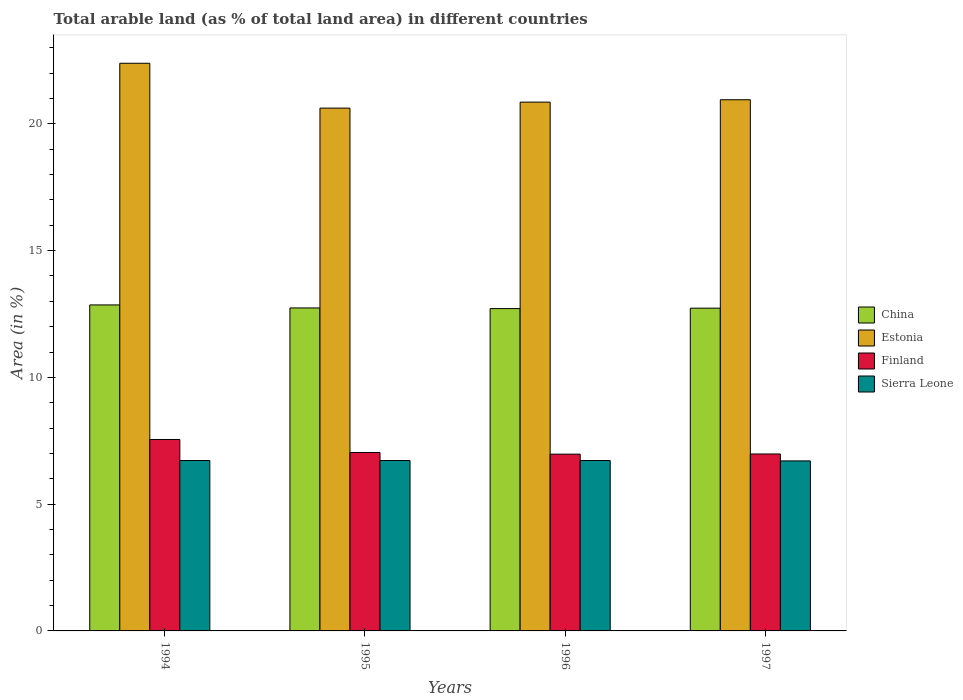How many different coloured bars are there?
Your answer should be compact. 4. How many groups of bars are there?
Make the answer very short. 4. Are the number of bars on each tick of the X-axis equal?
Your answer should be compact. Yes. How many bars are there on the 4th tick from the right?
Offer a very short reply. 4. What is the percentage of arable land in Estonia in 1994?
Make the answer very short. 22.39. Across all years, what is the maximum percentage of arable land in Finland?
Offer a terse response. 7.55. Across all years, what is the minimum percentage of arable land in China?
Provide a succinct answer. 12.71. In which year was the percentage of arable land in Estonia maximum?
Ensure brevity in your answer.  1994. What is the total percentage of arable land in Estonia in the graph?
Your answer should be compact. 84.81. What is the difference between the percentage of arable land in Finland in 1996 and the percentage of arable land in Estonia in 1994?
Ensure brevity in your answer.  -15.42. What is the average percentage of arable land in Estonia per year?
Give a very brief answer. 21.2. In the year 1994, what is the difference between the percentage of arable land in Finland and percentage of arable land in Estonia?
Your answer should be compact. -14.84. What is the ratio of the percentage of arable land in Finland in 1994 to that in 1995?
Provide a succinct answer. 1.07. What is the difference between the highest and the second highest percentage of arable land in Estonia?
Provide a succinct answer. 1.44. What is the difference between the highest and the lowest percentage of arable land in Estonia?
Provide a short and direct response. 1.77. What does the 4th bar from the left in 1995 represents?
Offer a terse response. Sierra Leone. What does the 1st bar from the right in 1994 represents?
Provide a short and direct response. Sierra Leone. Is it the case that in every year, the sum of the percentage of arable land in Finland and percentage of arable land in Estonia is greater than the percentage of arable land in Sierra Leone?
Your response must be concise. Yes. How many bars are there?
Your answer should be compact. 16. How many years are there in the graph?
Make the answer very short. 4. Are the values on the major ticks of Y-axis written in scientific E-notation?
Your answer should be very brief. No. Where does the legend appear in the graph?
Offer a terse response. Center right. How many legend labels are there?
Offer a very short reply. 4. How are the legend labels stacked?
Offer a terse response. Vertical. What is the title of the graph?
Your answer should be compact. Total arable land (as % of total land area) in different countries. What is the label or title of the Y-axis?
Provide a succinct answer. Area (in %). What is the Area (in %) of China in 1994?
Provide a succinct answer. 12.86. What is the Area (in %) in Estonia in 1994?
Keep it short and to the point. 22.39. What is the Area (in %) of Finland in 1994?
Keep it short and to the point. 7.55. What is the Area (in %) in Sierra Leone in 1994?
Provide a succinct answer. 6.72. What is the Area (in %) in China in 1995?
Make the answer very short. 12.74. What is the Area (in %) of Estonia in 1995?
Make the answer very short. 20.62. What is the Area (in %) in Finland in 1995?
Offer a terse response. 7.04. What is the Area (in %) of Sierra Leone in 1995?
Ensure brevity in your answer.  6.72. What is the Area (in %) in China in 1996?
Keep it short and to the point. 12.71. What is the Area (in %) in Estonia in 1996?
Provide a succinct answer. 20.85. What is the Area (in %) of Finland in 1996?
Ensure brevity in your answer.  6.97. What is the Area (in %) of Sierra Leone in 1996?
Offer a very short reply. 6.72. What is the Area (in %) of China in 1997?
Your answer should be compact. 12.73. What is the Area (in %) of Estonia in 1997?
Your response must be concise. 20.95. What is the Area (in %) of Finland in 1997?
Your answer should be compact. 6.98. What is the Area (in %) in Sierra Leone in 1997?
Provide a succinct answer. 6.71. Across all years, what is the maximum Area (in %) of China?
Give a very brief answer. 12.86. Across all years, what is the maximum Area (in %) of Estonia?
Provide a succinct answer. 22.39. Across all years, what is the maximum Area (in %) in Finland?
Provide a short and direct response. 7.55. Across all years, what is the maximum Area (in %) of Sierra Leone?
Offer a very short reply. 6.72. Across all years, what is the minimum Area (in %) in China?
Offer a terse response. 12.71. Across all years, what is the minimum Area (in %) in Estonia?
Make the answer very short. 20.62. Across all years, what is the minimum Area (in %) in Finland?
Make the answer very short. 6.97. Across all years, what is the minimum Area (in %) of Sierra Leone?
Provide a short and direct response. 6.71. What is the total Area (in %) in China in the graph?
Keep it short and to the point. 51.03. What is the total Area (in %) in Estonia in the graph?
Your answer should be compact. 84.81. What is the total Area (in %) in Finland in the graph?
Give a very brief answer. 28.54. What is the total Area (in %) of Sierra Leone in the graph?
Offer a terse response. 26.86. What is the difference between the Area (in %) in China in 1994 and that in 1995?
Your answer should be very brief. 0.12. What is the difference between the Area (in %) in Estonia in 1994 and that in 1995?
Provide a succinct answer. 1.77. What is the difference between the Area (in %) of Finland in 1994 and that in 1995?
Keep it short and to the point. 0.51. What is the difference between the Area (in %) in Sierra Leone in 1994 and that in 1995?
Your response must be concise. 0. What is the difference between the Area (in %) of China in 1994 and that in 1996?
Offer a terse response. 0.14. What is the difference between the Area (in %) of Estonia in 1994 and that in 1996?
Provide a succinct answer. 1.53. What is the difference between the Area (in %) in Finland in 1994 and that in 1996?
Provide a short and direct response. 0.58. What is the difference between the Area (in %) of Sierra Leone in 1994 and that in 1996?
Your answer should be compact. 0. What is the difference between the Area (in %) in China in 1994 and that in 1997?
Keep it short and to the point. 0.13. What is the difference between the Area (in %) in Estonia in 1994 and that in 1997?
Offer a terse response. 1.44. What is the difference between the Area (in %) of Finland in 1994 and that in 1997?
Your response must be concise. 0.57. What is the difference between the Area (in %) of Sierra Leone in 1994 and that in 1997?
Offer a terse response. 0.01. What is the difference between the Area (in %) of China in 1995 and that in 1996?
Offer a very short reply. 0.03. What is the difference between the Area (in %) in Estonia in 1995 and that in 1996?
Provide a short and direct response. -0.24. What is the difference between the Area (in %) in Finland in 1995 and that in 1996?
Keep it short and to the point. 0.07. What is the difference between the Area (in %) of Sierra Leone in 1995 and that in 1996?
Provide a succinct answer. 0. What is the difference between the Area (in %) in China in 1995 and that in 1997?
Your answer should be very brief. 0.01. What is the difference between the Area (in %) of Estonia in 1995 and that in 1997?
Your answer should be very brief. -0.33. What is the difference between the Area (in %) in Finland in 1995 and that in 1997?
Offer a terse response. 0.06. What is the difference between the Area (in %) of Sierra Leone in 1995 and that in 1997?
Ensure brevity in your answer.  0.01. What is the difference between the Area (in %) in China in 1996 and that in 1997?
Provide a short and direct response. -0.02. What is the difference between the Area (in %) of Estonia in 1996 and that in 1997?
Your answer should be very brief. -0.09. What is the difference between the Area (in %) of Finland in 1996 and that in 1997?
Make the answer very short. -0.01. What is the difference between the Area (in %) in Sierra Leone in 1996 and that in 1997?
Ensure brevity in your answer.  0.01. What is the difference between the Area (in %) in China in 1994 and the Area (in %) in Estonia in 1995?
Offer a terse response. -7.76. What is the difference between the Area (in %) in China in 1994 and the Area (in %) in Finland in 1995?
Provide a short and direct response. 5.82. What is the difference between the Area (in %) of China in 1994 and the Area (in %) of Sierra Leone in 1995?
Offer a very short reply. 6.14. What is the difference between the Area (in %) of Estonia in 1994 and the Area (in %) of Finland in 1995?
Give a very brief answer. 15.35. What is the difference between the Area (in %) of Estonia in 1994 and the Area (in %) of Sierra Leone in 1995?
Your answer should be very brief. 15.67. What is the difference between the Area (in %) of Finland in 1994 and the Area (in %) of Sierra Leone in 1995?
Provide a short and direct response. 0.83. What is the difference between the Area (in %) in China in 1994 and the Area (in %) in Estonia in 1996?
Offer a very short reply. -8. What is the difference between the Area (in %) of China in 1994 and the Area (in %) of Finland in 1996?
Provide a succinct answer. 5.89. What is the difference between the Area (in %) in China in 1994 and the Area (in %) in Sierra Leone in 1996?
Make the answer very short. 6.14. What is the difference between the Area (in %) of Estonia in 1994 and the Area (in %) of Finland in 1996?
Give a very brief answer. 15.42. What is the difference between the Area (in %) in Estonia in 1994 and the Area (in %) in Sierra Leone in 1996?
Make the answer very short. 15.67. What is the difference between the Area (in %) in Finland in 1994 and the Area (in %) in Sierra Leone in 1996?
Your response must be concise. 0.83. What is the difference between the Area (in %) of China in 1994 and the Area (in %) of Estonia in 1997?
Ensure brevity in your answer.  -8.09. What is the difference between the Area (in %) of China in 1994 and the Area (in %) of Finland in 1997?
Keep it short and to the point. 5.88. What is the difference between the Area (in %) in China in 1994 and the Area (in %) in Sierra Leone in 1997?
Offer a very short reply. 6.15. What is the difference between the Area (in %) of Estonia in 1994 and the Area (in %) of Finland in 1997?
Provide a succinct answer. 15.41. What is the difference between the Area (in %) of Estonia in 1994 and the Area (in %) of Sierra Leone in 1997?
Your answer should be very brief. 15.68. What is the difference between the Area (in %) in Finland in 1994 and the Area (in %) in Sierra Leone in 1997?
Keep it short and to the point. 0.84. What is the difference between the Area (in %) in China in 1995 and the Area (in %) in Estonia in 1996?
Offer a terse response. -8.12. What is the difference between the Area (in %) of China in 1995 and the Area (in %) of Finland in 1996?
Your response must be concise. 5.77. What is the difference between the Area (in %) of China in 1995 and the Area (in %) of Sierra Leone in 1996?
Offer a very short reply. 6.02. What is the difference between the Area (in %) of Estonia in 1995 and the Area (in %) of Finland in 1996?
Offer a very short reply. 13.65. What is the difference between the Area (in %) of Estonia in 1995 and the Area (in %) of Sierra Leone in 1996?
Keep it short and to the point. 13.9. What is the difference between the Area (in %) of Finland in 1995 and the Area (in %) of Sierra Leone in 1996?
Provide a succinct answer. 0.32. What is the difference between the Area (in %) of China in 1995 and the Area (in %) of Estonia in 1997?
Provide a short and direct response. -8.21. What is the difference between the Area (in %) in China in 1995 and the Area (in %) in Finland in 1997?
Your answer should be compact. 5.76. What is the difference between the Area (in %) in China in 1995 and the Area (in %) in Sierra Leone in 1997?
Give a very brief answer. 6.03. What is the difference between the Area (in %) in Estonia in 1995 and the Area (in %) in Finland in 1997?
Keep it short and to the point. 13.64. What is the difference between the Area (in %) in Estonia in 1995 and the Area (in %) in Sierra Leone in 1997?
Give a very brief answer. 13.91. What is the difference between the Area (in %) of Finland in 1995 and the Area (in %) of Sierra Leone in 1997?
Keep it short and to the point. 0.33. What is the difference between the Area (in %) in China in 1996 and the Area (in %) in Estonia in 1997?
Your response must be concise. -8.24. What is the difference between the Area (in %) of China in 1996 and the Area (in %) of Finland in 1997?
Your response must be concise. 5.73. What is the difference between the Area (in %) in China in 1996 and the Area (in %) in Sierra Leone in 1997?
Ensure brevity in your answer.  6.01. What is the difference between the Area (in %) of Estonia in 1996 and the Area (in %) of Finland in 1997?
Provide a succinct answer. 13.88. What is the difference between the Area (in %) in Estonia in 1996 and the Area (in %) in Sierra Leone in 1997?
Your answer should be very brief. 14.15. What is the difference between the Area (in %) in Finland in 1996 and the Area (in %) in Sierra Leone in 1997?
Your response must be concise. 0.27. What is the average Area (in %) of China per year?
Make the answer very short. 12.76. What is the average Area (in %) in Estonia per year?
Provide a short and direct response. 21.2. What is the average Area (in %) of Finland per year?
Provide a short and direct response. 7.13. What is the average Area (in %) in Sierra Leone per year?
Your answer should be compact. 6.72. In the year 1994, what is the difference between the Area (in %) of China and Area (in %) of Estonia?
Your answer should be very brief. -9.53. In the year 1994, what is the difference between the Area (in %) in China and Area (in %) in Finland?
Offer a very short reply. 5.31. In the year 1994, what is the difference between the Area (in %) of China and Area (in %) of Sierra Leone?
Offer a terse response. 6.14. In the year 1994, what is the difference between the Area (in %) of Estonia and Area (in %) of Finland?
Give a very brief answer. 14.84. In the year 1994, what is the difference between the Area (in %) of Estonia and Area (in %) of Sierra Leone?
Your answer should be very brief. 15.67. In the year 1994, what is the difference between the Area (in %) of Finland and Area (in %) of Sierra Leone?
Ensure brevity in your answer.  0.83. In the year 1995, what is the difference between the Area (in %) of China and Area (in %) of Estonia?
Provide a succinct answer. -7.88. In the year 1995, what is the difference between the Area (in %) of China and Area (in %) of Finland?
Your response must be concise. 5.7. In the year 1995, what is the difference between the Area (in %) of China and Area (in %) of Sierra Leone?
Provide a succinct answer. 6.02. In the year 1995, what is the difference between the Area (in %) of Estonia and Area (in %) of Finland?
Keep it short and to the point. 13.58. In the year 1995, what is the difference between the Area (in %) of Estonia and Area (in %) of Sierra Leone?
Your answer should be compact. 13.9. In the year 1995, what is the difference between the Area (in %) in Finland and Area (in %) in Sierra Leone?
Provide a succinct answer. 0.32. In the year 1996, what is the difference between the Area (in %) of China and Area (in %) of Estonia?
Your response must be concise. -8.14. In the year 1996, what is the difference between the Area (in %) in China and Area (in %) in Finland?
Make the answer very short. 5.74. In the year 1996, what is the difference between the Area (in %) in China and Area (in %) in Sierra Leone?
Provide a succinct answer. 5.99. In the year 1996, what is the difference between the Area (in %) in Estonia and Area (in %) in Finland?
Provide a short and direct response. 13.88. In the year 1996, what is the difference between the Area (in %) in Estonia and Area (in %) in Sierra Leone?
Provide a short and direct response. 14.13. In the year 1996, what is the difference between the Area (in %) in Finland and Area (in %) in Sierra Leone?
Offer a very short reply. 0.25. In the year 1997, what is the difference between the Area (in %) of China and Area (in %) of Estonia?
Provide a short and direct response. -8.22. In the year 1997, what is the difference between the Area (in %) in China and Area (in %) in Finland?
Your answer should be compact. 5.75. In the year 1997, what is the difference between the Area (in %) of China and Area (in %) of Sierra Leone?
Give a very brief answer. 6.02. In the year 1997, what is the difference between the Area (in %) in Estonia and Area (in %) in Finland?
Make the answer very short. 13.97. In the year 1997, what is the difference between the Area (in %) of Estonia and Area (in %) of Sierra Leone?
Provide a succinct answer. 14.24. In the year 1997, what is the difference between the Area (in %) in Finland and Area (in %) in Sierra Leone?
Provide a short and direct response. 0.27. What is the ratio of the Area (in %) of China in 1994 to that in 1995?
Your answer should be very brief. 1.01. What is the ratio of the Area (in %) of Estonia in 1994 to that in 1995?
Provide a short and direct response. 1.09. What is the ratio of the Area (in %) of Finland in 1994 to that in 1995?
Make the answer very short. 1.07. What is the ratio of the Area (in %) of Sierra Leone in 1994 to that in 1995?
Your answer should be compact. 1. What is the ratio of the Area (in %) of China in 1994 to that in 1996?
Keep it short and to the point. 1.01. What is the ratio of the Area (in %) in Estonia in 1994 to that in 1996?
Offer a very short reply. 1.07. What is the ratio of the Area (in %) of Finland in 1994 to that in 1996?
Ensure brevity in your answer.  1.08. What is the ratio of the Area (in %) in Estonia in 1994 to that in 1997?
Provide a short and direct response. 1.07. What is the ratio of the Area (in %) of Finland in 1994 to that in 1997?
Provide a succinct answer. 1.08. What is the ratio of the Area (in %) of China in 1995 to that in 1996?
Give a very brief answer. 1. What is the ratio of the Area (in %) in Estonia in 1995 to that in 1996?
Offer a very short reply. 0.99. What is the ratio of the Area (in %) in Finland in 1995 to that in 1996?
Your answer should be compact. 1.01. What is the ratio of the Area (in %) in Sierra Leone in 1995 to that in 1996?
Your answer should be very brief. 1. What is the ratio of the Area (in %) in China in 1995 to that in 1997?
Make the answer very short. 1. What is the ratio of the Area (in %) in Estonia in 1995 to that in 1997?
Provide a short and direct response. 0.98. What is the ratio of the Area (in %) of Finland in 1995 to that in 1997?
Offer a terse response. 1.01. What is the ratio of the Area (in %) in Estonia in 1996 to that in 1997?
Provide a short and direct response. 1. What is the ratio of the Area (in %) in Sierra Leone in 1996 to that in 1997?
Make the answer very short. 1. What is the difference between the highest and the second highest Area (in %) in China?
Your response must be concise. 0.12. What is the difference between the highest and the second highest Area (in %) in Estonia?
Offer a very short reply. 1.44. What is the difference between the highest and the second highest Area (in %) of Finland?
Offer a terse response. 0.51. What is the difference between the highest and the second highest Area (in %) in Sierra Leone?
Make the answer very short. 0. What is the difference between the highest and the lowest Area (in %) in China?
Give a very brief answer. 0.14. What is the difference between the highest and the lowest Area (in %) in Estonia?
Provide a succinct answer. 1.77. What is the difference between the highest and the lowest Area (in %) of Finland?
Your response must be concise. 0.58. What is the difference between the highest and the lowest Area (in %) in Sierra Leone?
Provide a succinct answer. 0.01. 